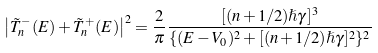Convert formula to latex. <formula><loc_0><loc_0><loc_500><loc_500>\left | \tilde { T } ^ { - } _ { n } ( E ) + \tilde { T } ^ { + } _ { n } ( E ) \right | ^ { 2 } = \frac { 2 } { \pi } \frac { [ ( n + 1 / 2 ) \hslash \gamma ] ^ { 3 } } { \{ ( E - V _ { 0 } ) ^ { 2 } + [ ( n + 1 / 2 ) \hslash \gamma ] ^ { 2 } \} ^ { 2 } }</formula> 